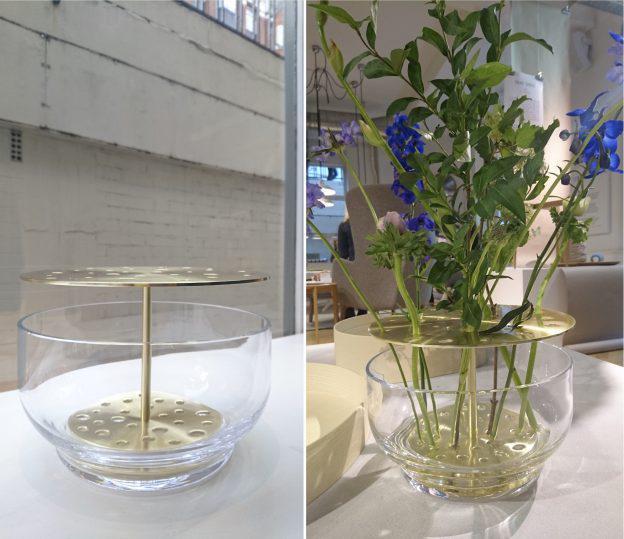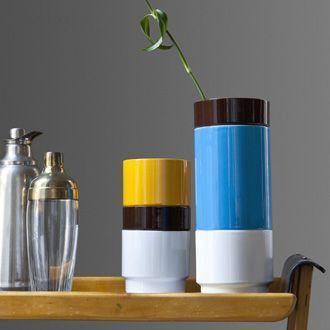The first image is the image on the left, the second image is the image on the right. Considering the images on both sides, is "An image shows vases with bold horizontal bands of color." valid? Answer yes or no. Yes. 